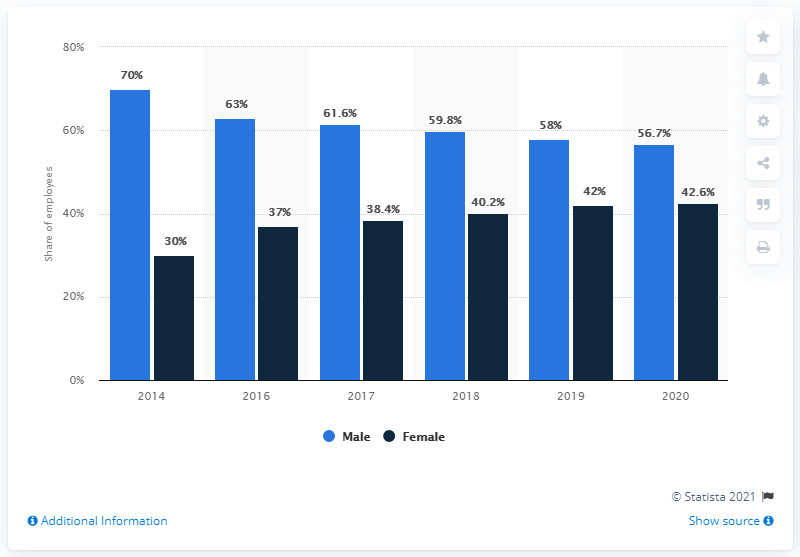Which year saw the smallest difference between the number of male and female employees?
 2020 